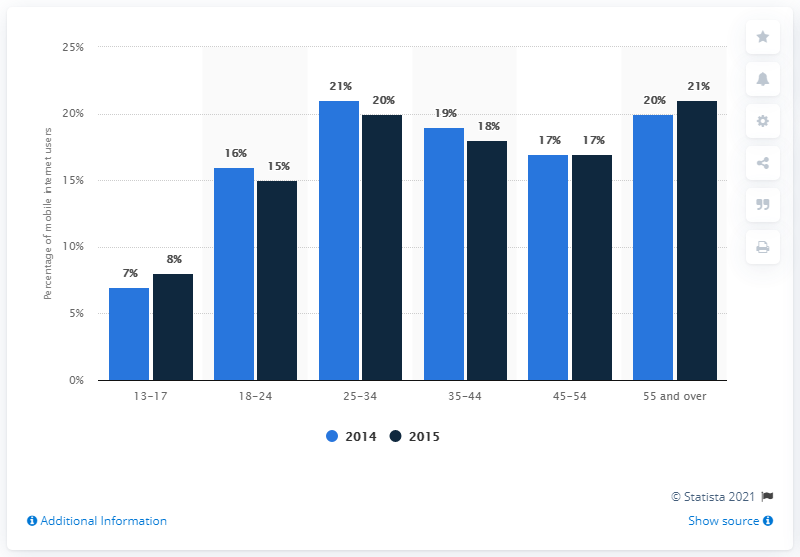Specify some key components in this picture. The value of the tallest blue bar is 21. In 2015, 21 percent of people accessed the internet via a mobile device, with the highest percentage being among those aged 55 and older. The sum of the two bars in 13-17 is 15. 